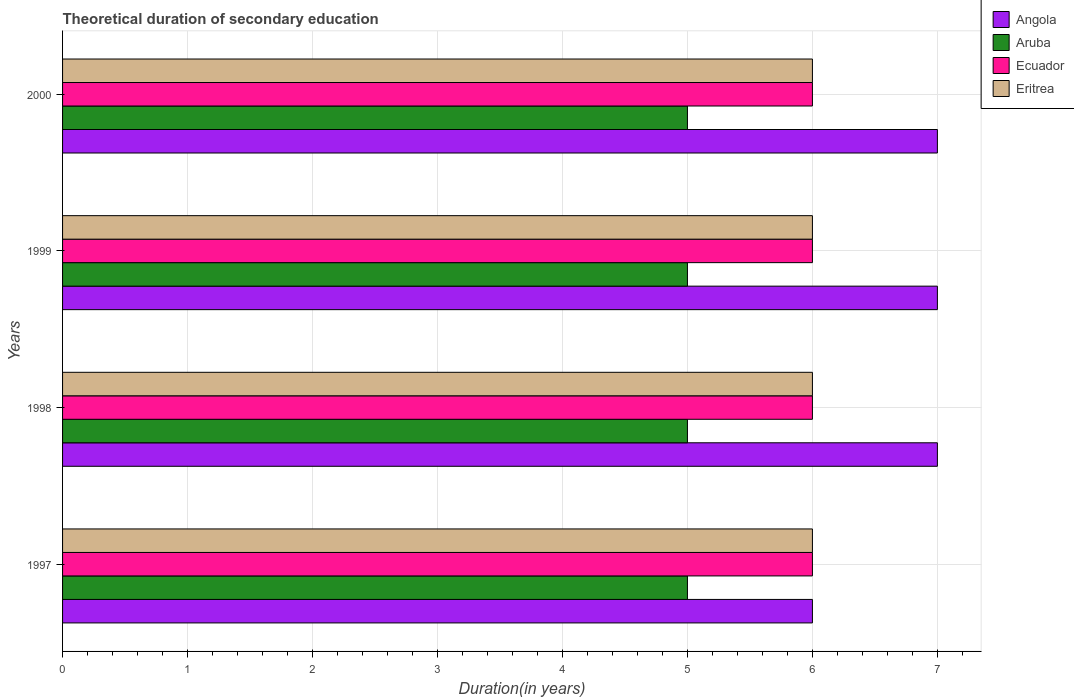How many different coloured bars are there?
Offer a very short reply. 4. What is the total theoretical duration of secondary education in Angola in 2000?
Make the answer very short. 7. Across all years, what is the maximum total theoretical duration of secondary education in Angola?
Provide a succinct answer. 7. Across all years, what is the minimum total theoretical duration of secondary education in Angola?
Your answer should be very brief. 6. In which year was the total theoretical duration of secondary education in Ecuador minimum?
Your answer should be very brief. 1997. What is the total total theoretical duration of secondary education in Eritrea in the graph?
Make the answer very short. 24. What is the difference between the total theoretical duration of secondary education in Ecuador in 1997 and that in 2000?
Make the answer very short. 0. What is the difference between the total theoretical duration of secondary education in Aruba in 2000 and the total theoretical duration of secondary education in Angola in 1999?
Make the answer very short. -2. What is the average total theoretical duration of secondary education in Angola per year?
Offer a terse response. 6.75. In the year 1998, what is the difference between the total theoretical duration of secondary education in Ecuador and total theoretical duration of secondary education in Aruba?
Your response must be concise. 1. Is the total theoretical duration of secondary education in Angola in 1997 less than that in 1999?
Make the answer very short. Yes. Is the difference between the total theoretical duration of secondary education in Ecuador in 1998 and 1999 greater than the difference between the total theoretical duration of secondary education in Aruba in 1998 and 1999?
Ensure brevity in your answer.  No. Is the sum of the total theoretical duration of secondary education in Angola in 1999 and 2000 greater than the maximum total theoretical duration of secondary education in Ecuador across all years?
Keep it short and to the point. Yes. What does the 1st bar from the top in 1998 represents?
Offer a very short reply. Eritrea. What does the 2nd bar from the bottom in 1997 represents?
Provide a succinct answer. Aruba. Are all the bars in the graph horizontal?
Offer a terse response. Yes. How many years are there in the graph?
Provide a succinct answer. 4. Does the graph contain any zero values?
Provide a succinct answer. No. How are the legend labels stacked?
Make the answer very short. Vertical. What is the title of the graph?
Offer a terse response. Theoretical duration of secondary education. What is the label or title of the X-axis?
Offer a very short reply. Duration(in years). What is the Duration(in years) of Angola in 1997?
Keep it short and to the point. 6. What is the Duration(in years) in Aruba in 1997?
Offer a very short reply. 5. What is the Duration(in years) of Ecuador in 1997?
Make the answer very short. 6. What is the Duration(in years) of Eritrea in 1997?
Give a very brief answer. 6. What is the Duration(in years) in Ecuador in 1998?
Offer a very short reply. 6. What is the Duration(in years) of Angola in 1999?
Make the answer very short. 7. What is the Duration(in years) in Aruba in 1999?
Offer a terse response. 5. What is the Duration(in years) of Eritrea in 1999?
Give a very brief answer. 6. What is the Duration(in years) of Angola in 2000?
Your response must be concise. 7. What is the Duration(in years) in Aruba in 2000?
Keep it short and to the point. 5. What is the Duration(in years) in Ecuador in 2000?
Offer a very short reply. 6. What is the Duration(in years) in Eritrea in 2000?
Offer a terse response. 6. Across all years, what is the maximum Duration(in years) in Angola?
Your answer should be compact. 7. Across all years, what is the maximum Duration(in years) in Aruba?
Give a very brief answer. 5. Across all years, what is the maximum Duration(in years) of Ecuador?
Give a very brief answer. 6. Across all years, what is the minimum Duration(in years) in Angola?
Offer a terse response. 6. Across all years, what is the minimum Duration(in years) of Aruba?
Provide a succinct answer. 5. Across all years, what is the minimum Duration(in years) of Eritrea?
Offer a very short reply. 6. What is the total Duration(in years) in Eritrea in the graph?
Keep it short and to the point. 24. What is the difference between the Duration(in years) of Ecuador in 1997 and that in 1998?
Keep it short and to the point. 0. What is the difference between the Duration(in years) in Eritrea in 1997 and that in 1998?
Provide a succinct answer. 0. What is the difference between the Duration(in years) of Angola in 1997 and that in 1999?
Your answer should be compact. -1. What is the difference between the Duration(in years) in Eritrea in 1997 and that in 1999?
Provide a succinct answer. 0. What is the difference between the Duration(in years) of Angola in 1997 and that in 2000?
Offer a very short reply. -1. What is the difference between the Duration(in years) in Aruba in 1997 and that in 2000?
Offer a terse response. 0. What is the difference between the Duration(in years) of Eritrea in 1997 and that in 2000?
Provide a succinct answer. 0. What is the difference between the Duration(in years) in Eritrea in 1998 and that in 1999?
Your answer should be very brief. 0. What is the difference between the Duration(in years) in Angola in 1998 and that in 2000?
Your answer should be compact. 0. What is the difference between the Duration(in years) of Ecuador in 1998 and that in 2000?
Offer a terse response. 0. What is the difference between the Duration(in years) in Eritrea in 1998 and that in 2000?
Ensure brevity in your answer.  0. What is the difference between the Duration(in years) in Angola in 1999 and that in 2000?
Provide a succinct answer. 0. What is the difference between the Duration(in years) of Aruba in 1999 and that in 2000?
Make the answer very short. 0. What is the difference between the Duration(in years) of Ecuador in 1999 and that in 2000?
Give a very brief answer. 0. What is the difference between the Duration(in years) in Angola in 1997 and the Duration(in years) in Aruba in 1998?
Keep it short and to the point. 1. What is the difference between the Duration(in years) in Angola in 1997 and the Duration(in years) in Ecuador in 1998?
Ensure brevity in your answer.  0. What is the difference between the Duration(in years) in Aruba in 1997 and the Duration(in years) in Ecuador in 1998?
Ensure brevity in your answer.  -1. What is the difference between the Duration(in years) of Aruba in 1997 and the Duration(in years) of Eritrea in 1998?
Your answer should be compact. -1. What is the difference between the Duration(in years) of Ecuador in 1997 and the Duration(in years) of Eritrea in 1998?
Provide a succinct answer. 0. What is the difference between the Duration(in years) of Angola in 1997 and the Duration(in years) of Eritrea in 1999?
Your answer should be compact. 0. What is the difference between the Duration(in years) in Aruba in 1997 and the Duration(in years) in Eritrea in 1999?
Your answer should be compact. -1. What is the difference between the Duration(in years) of Ecuador in 1997 and the Duration(in years) of Eritrea in 2000?
Offer a very short reply. 0. What is the difference between the Duration(in years) of Angola in 1998 and the Duration(in years) of Aruba in 1999?
Offer a terse response. 2. What is the difference between the Duration(in years) in Angola in 1998 and the Duration(in years) in Eritrea in 1999?
Your answer should be very brief. 1. What is the difference between the Duration(in years) of Aruba in 1998 and the Duration(in years) of Ecuador in 1999?
Ensure brevity in your answer.  -1. What is the difference between the Duration(in years) of Aruba in 1998 and the Duration(in years) of Eritrea in 1999?
Make the answer very short. -1. What is the difference between the Duration(in years) of Angola in 1998 and the Duration(in years) of Ecuador in 2000?
Keep it short and to the point. 1. What is the difference between the Duration(in years) of Angola in 1998 and the Duration(in years) of Eritrea in 2000?
Ensure brevity in your answer.  1. What is the difference between the Duration(in years) in Aruba in 1998 and the Duration(in years) in Eritrea in 2000?
Give a very brief answer. -1. What is the difference between the Duration(in years) in Ecuador in 1998 and the Duration(in years) in Eritrea in 2000?
Ensure brevity in your answer.  0. What is the difference between the Duration(in years) of Angola in 1999 and the Duration(in years) of Aruba in 2000?
Ensure brevity in your answer.  2. What is the difference between the Duration(in years) of Angola in 1999 and the Duration(in years) of Ecuador in 2000?
Ensure brevity in your answer.  1. What is the difference between the Duration(in years) of Angola in 1999 and the Duration(in years) of Eritrea in 2000?
Offer a terse response. 1. What is the average Duration(in years) in Angola per year?
Keep it short and to the point. 6.75. In the year 1998, what is the difference between the Duration(in years) of Angola and Duration(in years) of Eritrea?
Offer a very short reply. 1. In the year 1998, what is the difference between the Duration(in years) of Aruba and Duration(in years) of Eritrea?
Ensure brevity in your answer.  -1. In the year 1999, what is the difference between the Duration(in years) in Angola and Duration(in years) in Aruba?
Provide a succinct answer. 2. In the year 1999, what is the difference between the Duration(in years) in Angola and Duration(in years) in Eritrea?
Your answer should be compact. 1. In the year 1999, what is the difference between the Duration(in years) in Aruba and Duration(in years) in Eritrea?
Ensure brevity in your answer.  -1. In the year 1999, what is the difference between the Duration(in years) in Ecuador and Duration(in years) in Eritrea?
Your response must be concise. 0. In the year 2000, what is the difference between the Duration(in years) of Angola and Duration(in years) of Aruba?
Your response must be concise. 2. In the year 2000, what is the difference between the Duration(in years) of Angola and Duration(in years) of Eritrea?
Provide a short and direct response. 1. In the year 2000, what is the difference between the Duration(in years) of Aruba and Duration(in years) of Eritrea?
Your answer should be compact. -1. What is the ratio of the Duration(in years) of Angola in 1997 to that in 1998?
Offer a very short reply. 0.86. What is the ratio of the Duration(in years) of Aruba in 1997 to that in 1998?
Provide a short and direct response. 1. What is the ratio of the Duration(in years) in Ecuador in 1997 to that in 1998?
Keep it short and to the point. 1. What is the ratio of the Duration(in years) of Eritrea in 1997 to that in 1998?
Provide a short and direct response. 1. What is the ratio of the Duration(in years) in Ecuador in 1997 to that in 1999?
Provide a succinct answer. 1. What is the ratio of the Duration(in years) in Eritrea in 1997 to that in 1999?
Keep it short and to the point. 1. What is the ratio of the Duration(in years) in Eritrea in 1997 to that in 2000?
Your answer should be compact. 1. What is the ratio of the Duration(in years) of Eritrea in 1998 to that in 1999?
Give a very brief answer. 1. What is the ratio of the Duration(in years) of Angola in 1998 to that in 2000?
Your response must be concise. 1. What is the ratio of the Duration(in years) in Aruba in 1998 to that in 2000?
Give a very brief answer. 1. What is the ratio of the Duration(in years) of Ecuador in 1998 to that in 2000?
Offer a very short reply. 1. What is the ratio of the Duration(in years) of Angola in 1999 to that in 2000?
Your response must be concise. 1. What is the ratio of the Duration(in years) in Aruba in 1999 to that in 2000?
Your response must be concise. 1. What is the difference between the highest and the second highest Duration(in years) in Aruba?
Your answer should be very brief. 0. What is the difference between the highest and the second highest Duration(in years) in Eritrea?
Give a very brief answer. 0. What is the difference between the highest and the lowest Duration(in years) in Angola?
Your answer should be compact. 1. What is the difference between the highest and the lowest Duration(in years) of Ecuador?
Offer a very short reply. 0. What is the difference between the highest and the lowest Duration(in years) in Eritrea?
Your answer should be very brief. 0. 